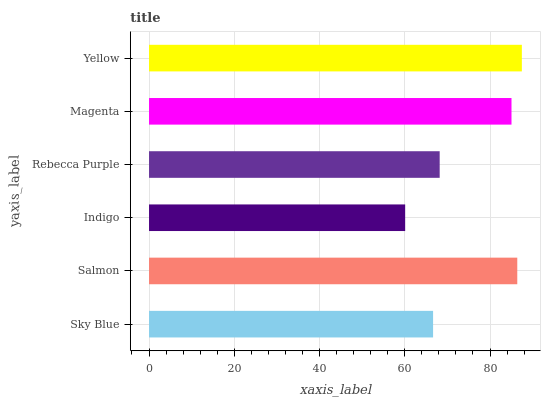Is Indigo the minimum?
Answer yes or no. Yes. Is Yellow the maximum?
Answer yes or no. Yes. Is Salmon the minimum?
Answer yes or no. No. Is Salmon the maximum?
Answer yes or no. No. Is Salmon greater than Sky Blue?
Answer yes or no. Yes. Is Sky Blue less than Salmon?
Answer yes or no. Yes. Is Sky Blue greater than Salmon?
Answer yes or no. No. Is Salmon less than Sky Blue?
Answer yes or no. No. Is Magenta the high median?
Answer yes or no. Yes. Is Rebecca Purple the low median?
Answer yes or no. Yes. Is Indigo the high median?
Answer yes or no. No. Is Salmon the low median?
Answer yes or no. No. 